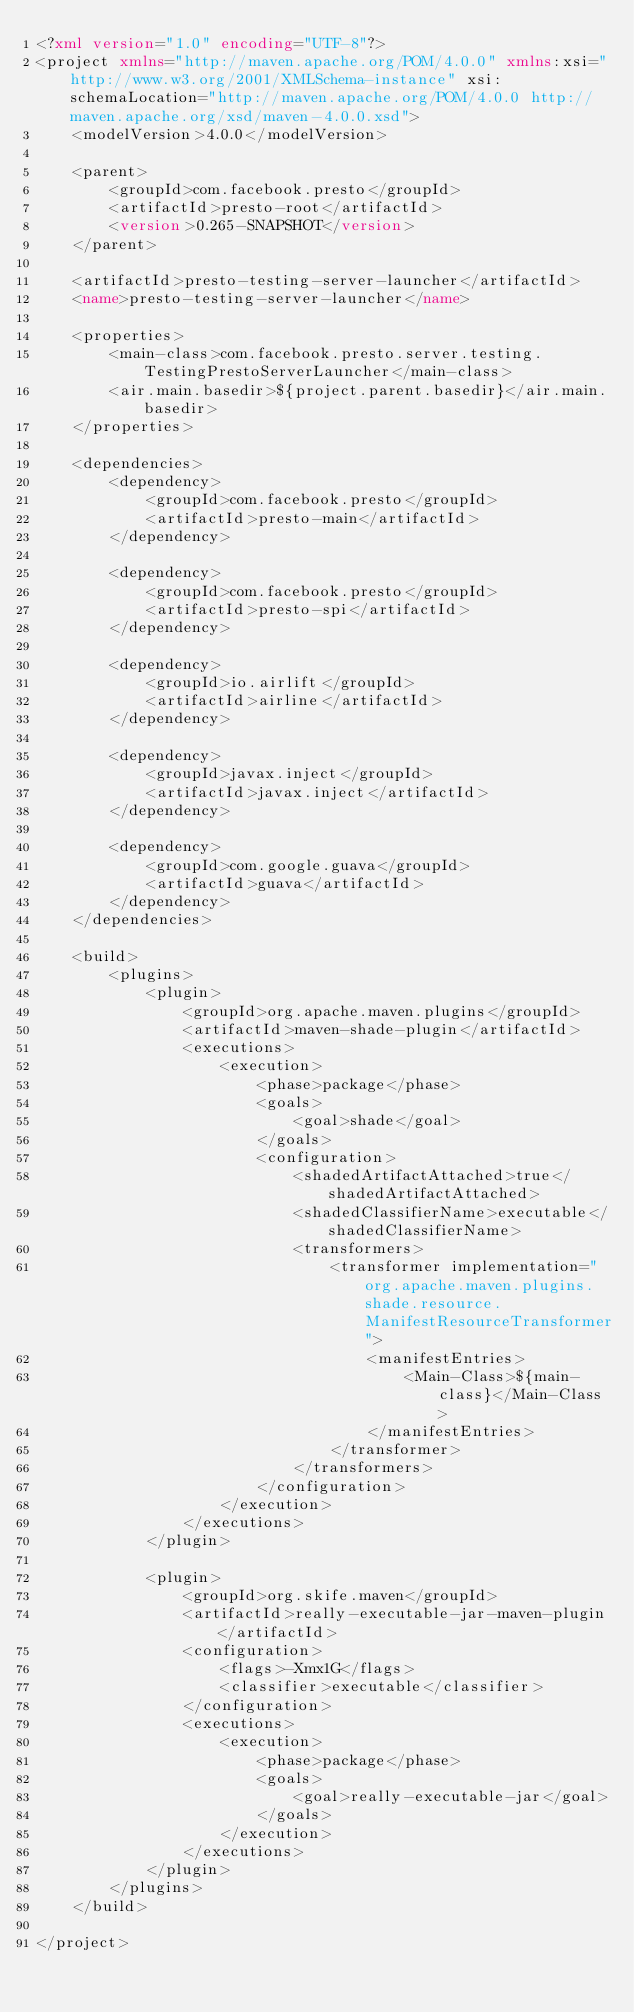<code> <loc_0><loc_0><loc_500><loc_500><_XML_><?xml version="1.0" encoding="UTF-8"?>
<project xmlns="http://maven.apache.org/POM/4.0.0" xmlns:xsi="http://www.w3.org/2001/XMLSchema-instance" xsi:schemaLocation="http://maven.apache.org/POM/4.0.0 http://maven.apache.org/xsd/maven-4.0.0.xsd">
    <modelVersion>4.0.0</modelVersion>

    <parent>
        <groupId>com.facebook.presto</groupId>
        <artifactId>presto-root</artifactId>
        <version>0.265-SNAPSHOT</version>
    </parent>

    <artifactId>presto-testing-server-launcher</artifactId>
    <name>presto-testing-server-launcher</name>

    <properties>
        <main-class>com.facebook.presto.server.testing.TestingPrestoServerLauncher</main-class>
        <air.main.basedir>${project.parent.basedir}</air.main.basedir>
    </properties>

    <dependencies>
        <dependency>
            <groupId>com.facebook.presto</groupId>
            <artifactId>presto-main</artifactId>
        </dependency>

        <dependency>
            <groupId>com.facebook.presto</groupId>
            <artifactId>presto-spi</artifactId>
        </dependency>

        <dependency>
            <groupId>io.airlift</groupId>
            <artifactId>airline</artifactId>
        </dependency>

        <dependency>
            <groupId>javax.inject</groupId>
            <artifactId>javax.inject</artifactId>
        </dependency>

        <dependency>
            <groupId>com.google.guava</groupId>
            <artifactId>guava</artifactId>
        </dependency>
    </dependencies>

    <build>
        <plugins>
            <plugin>
                <groupId>org.apache.maven.plugins</groupId>
                <artifactId>maven-shade-plugin</artifactId>
                <executions>
                    <execution>
                        <phase>package</phase>
                        <goals>
                            <goal>shade</goal>
                        </goals>
                        <configuration>
                            <shadedArtifactAttached>true</shadedArtifactAttached>
                            <shadedClassifierName>executable</shadedClassifierName>
                            <transformers>
                                <transformer implementation="org.apache.maven.plugins.shade.resource.ManifestResourceTransformer">
                                    <manifestEntries>
                                        <Main-Class>${main-class}</Main-Class>
                                    </manifestEntries>
                                </transformer>
                            </transformers>
                        </configuration>
                    </execution>
                </executions>
            </plugin>

            <plugin>
                <groupId>org.skife.maven</groupId>
                <artifactId>really-executable-jar-maven-plugin</artifactId>
                <configuration>
                    <flags>-Xmx1G</flags>
                    <classifier>executable</classifier>
                </configuration>
                <executions>
                    <execution>
                        <phase>package</phase>
                        <goals>
                            <goal>really-executable-jar</goal>
                        </goals>
                    </execution>
                </executions>
            </plugin>
        </plugins>
    </build>

</project>
</code> 